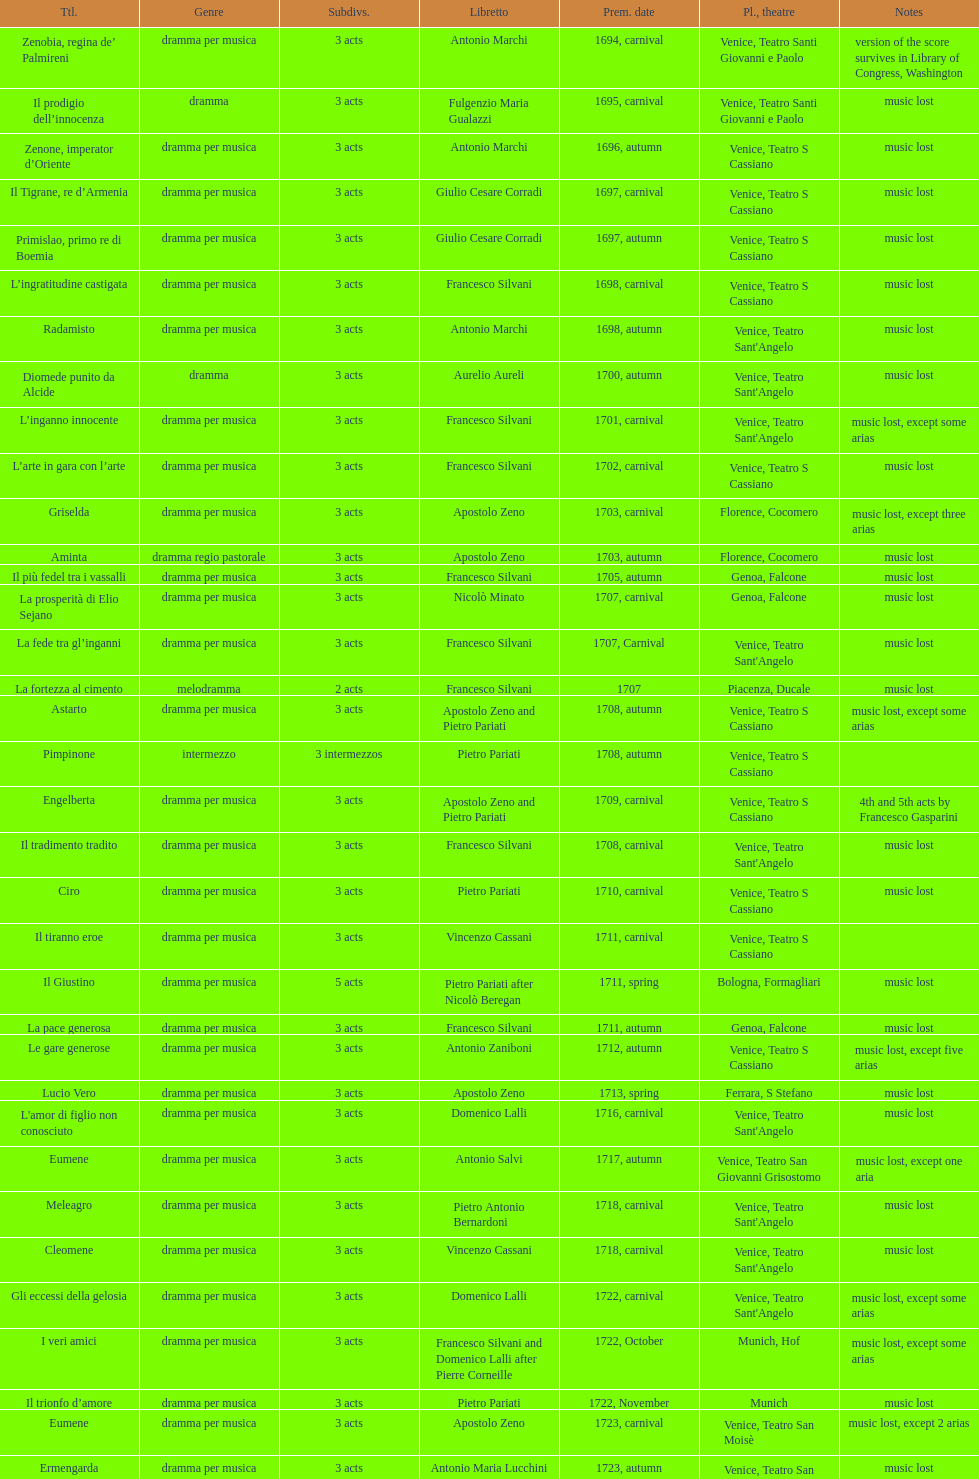Which opera features the most acts, la fortezza al cimento or astarto? Astarto. 